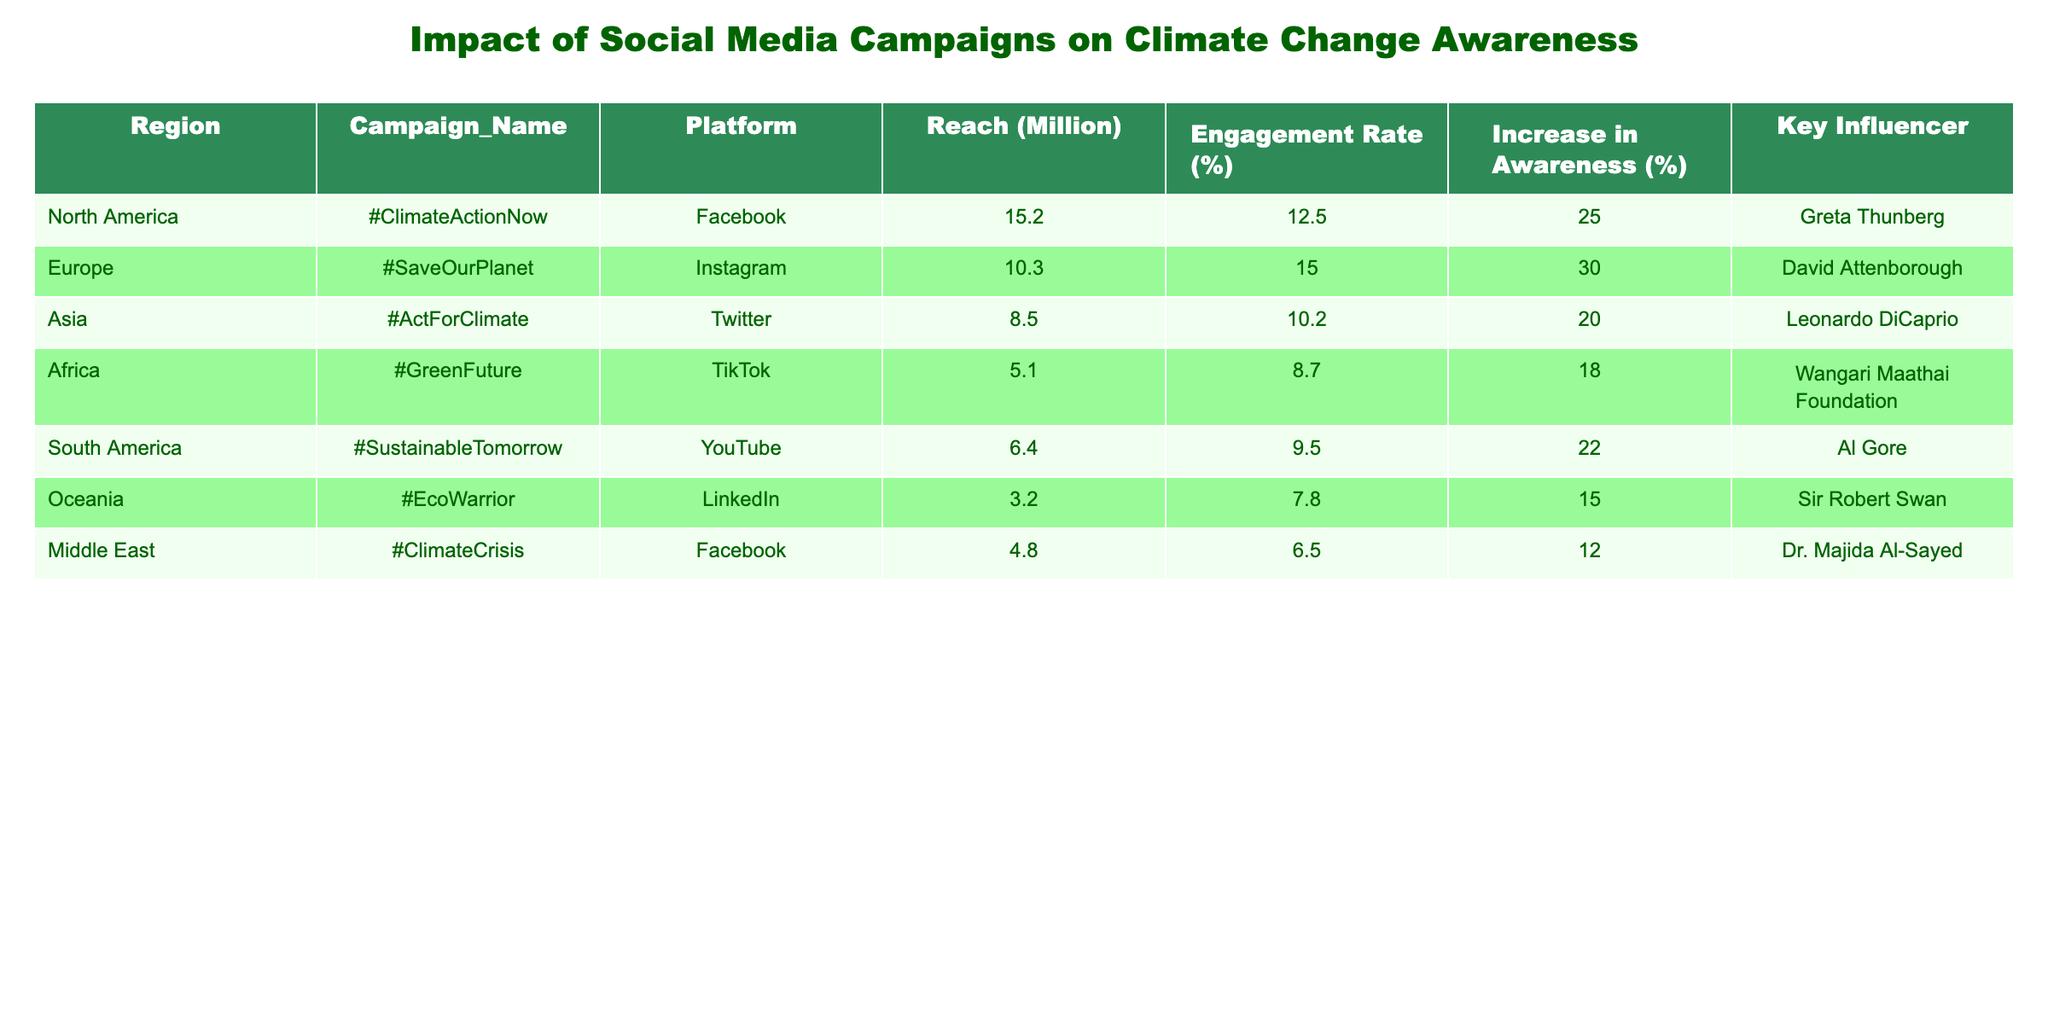What is the reach of the "#ClimateActionNow" campaign in North America? The table lists the "Reach (Million)" column for each campaign. The reach for "#ClimateActionNow" in North America is stated as 15.2 million.
Answer: 15.2 million Which region had the lowest engagement rate? By examining the "Engagement Rate (%)" column, we see that Oceania has the lowest rate at 7.8%.
Answer: 7.8% What campaign had the highest increase in awareness percentage, and what was that percentage? The "Increase in Awareness (%)" column shows that "#SaveOurPlanet" in Europe had the highest percentage, which is 30%.
Answer: #SaveOurPlanet, 30% Is the engagement rate for campaigns on TikTok higher than for those on LinkedIn? The engagement rate for TikTok (8.7%) is higher than that for LinkedIn (7.8%), thus the statement is true.
Answer: Yes What is the total reach of all campaigns across all regions? The total reach is calculated by adding all the reach values: 15.2 + 10.3 + 8.5 + 5.1 + 6.4 + 3.2 + 4.8 = 53.5 million.
Answer: 53.5 million How does the increase in awareness from the "#SustainableTomorrow" campaign compare to that of the "#GreenFuture" campaign? The "#SustainableTomorrow" campaign has an increase in awareness of 22%, while "#GreenFuture" has 18%. Therefore, "#SustainableTomorrow" has a higher increase by 4%.
Answer: 4% higher Which key influencer is associated with the campaign that has the smallest reach, and what is that reach? The campaign with the smallest reach is "#EcoWarrior" in Oceania, which has a reach of 3.2 million, associated with Sir Robert Swan.
Answer: Sir Robert Swan, 3.2 million In terms of public awareness increase, which region shows the least impact among the campaigns? The "Increase in Awareness (%)" values show that the Middle East campaign "#ClimateCrisis" had the least impact with only 12%.
Answer: Middle East, 12% What is the average engagement rate across all campaigns? To find the average, sum all engagement rates: (12.5 + 15.0 + 10.2 + 8.7 + 9.5 + 7.8 + 6.5) = 69.2%, then divide by 7 (the number of campaigns), which equals approximately 9.89%.
Answer: Approximately 9.89% Which platform had the highest reach for its campaign? By comparing the reach values, Facebook's "#ClimateActionNow" with 15.2 million has the highest reach compared to all platforms.
Answer: Facebook, 15.2 million 